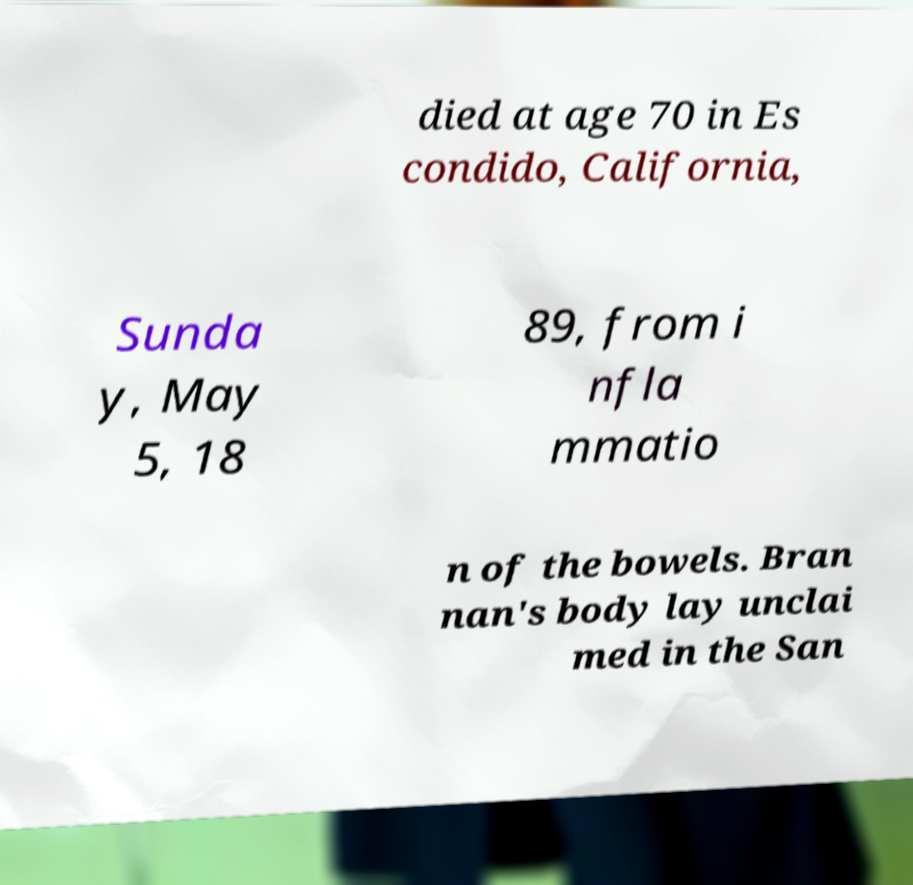I need the written content from this picture converted into text. Can you do that? died at age 70 in Es condido, California, Sunda y, May 5, 18 89, from i nfla mmatio n of the bowels. Bran nan's body lay unclai med in the San 